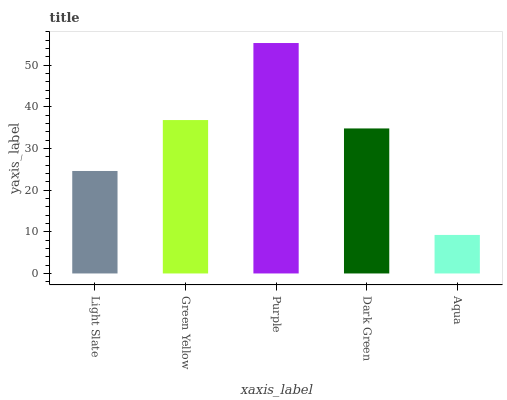Is Aqua the minimum?
Answer yes or no. Yes. Is Purple the maximum?
Answer yes or no. Yes. Is Green Yellow the minimum?
Answer yes or no. No. Is Green Yellow the maximum?
Answer yes or no. No. Is Green Yellow greater than Light Slate?
Answer yes or no. Yes. Is Light Slate less than Green Yellow?
Answer yes or no. Yes. Is Light Slate greater than Green Yellow?
Answer yes or no. No. Is Green Yellow less than Light Slate?
Answer yes or no. No. Is Dark Green the high median?
Answer yes or no. Yes. Is Dark Green the low median?
Answer yes or no. Yes. Is Green Yellow the high median?
Answer yes or no. No. Is Green Yellow the low median?
Answer yes or no. No. 